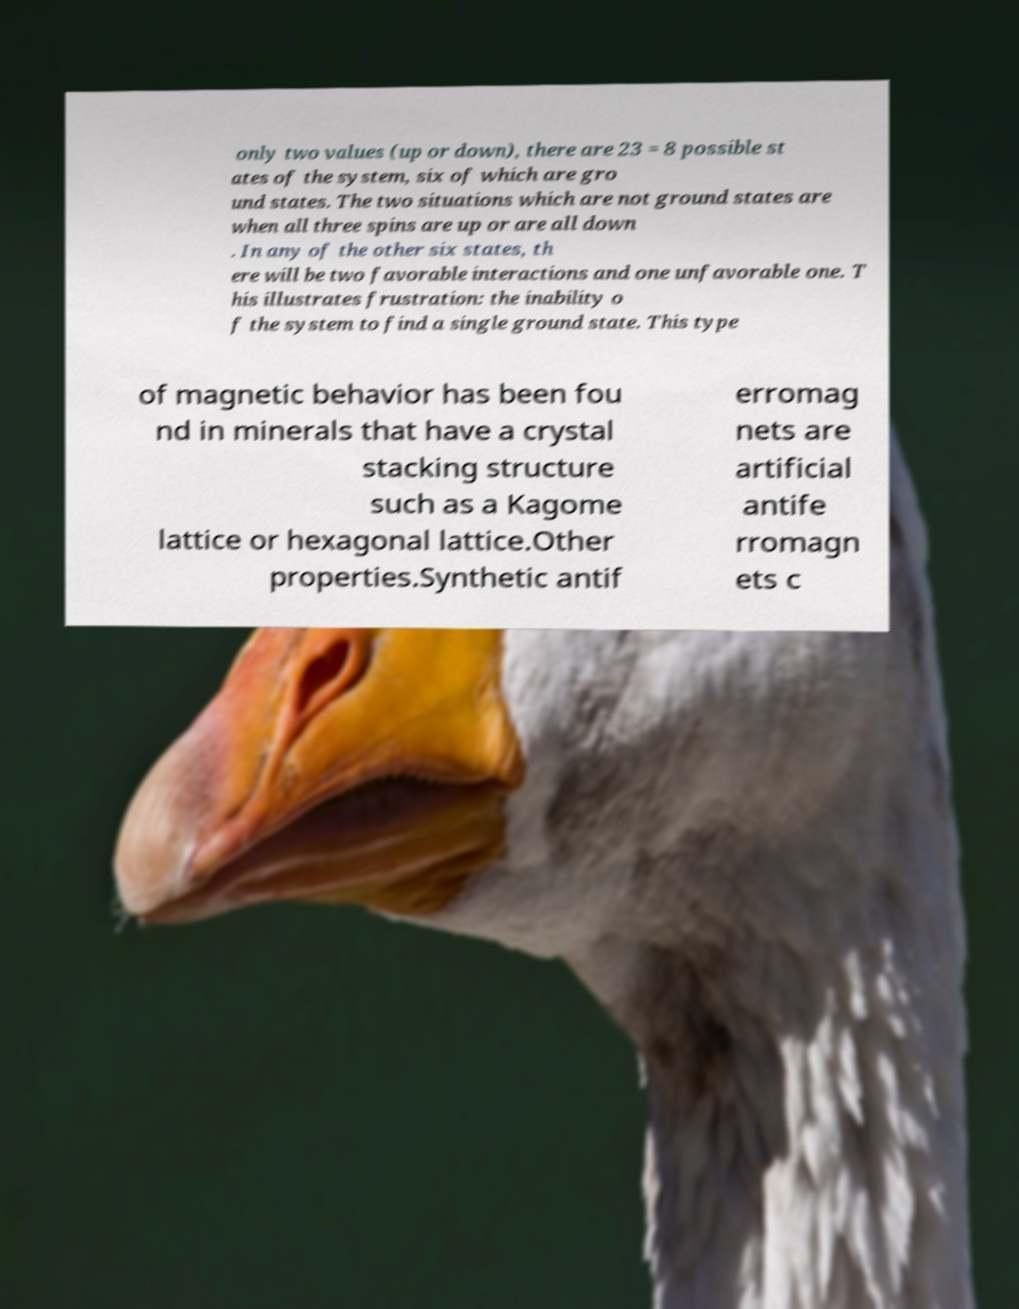Please identify and transcribe the text found in this image. only two values (up or down), there are 23 = 8 possible st ates of the system, six of which are gro und states. The two situations which are not ground states are when all three spins are up or are all down . In any of the other six states, th ere will be two favorable interactions and one unfavorable one. T his illustrates frustration: the inability o f the system to find a single ground state. This type of magnetic behavior has been fou nd in minerals that have a crystal stacking structure such as a Kagome lattice or hexagonal lattice.Other properties.Synthetic antif erromag nets are artificial antife rromagn ets c 